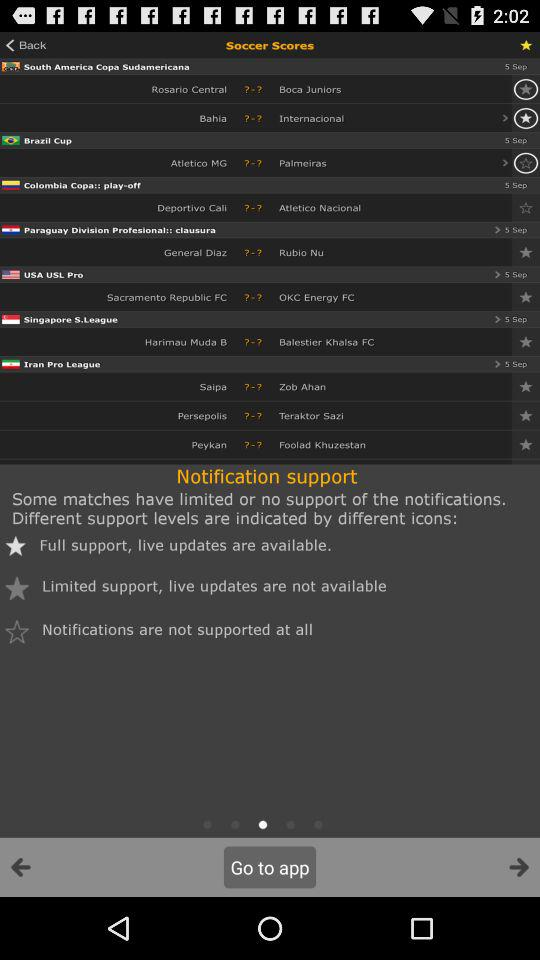How many different notification support levels are there?
Answer the question using a single word or phrase. 3 